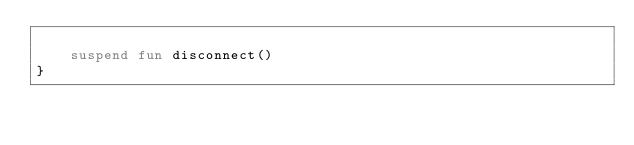<code> <loc_0><loc_0><loc_500><loc_500><_Kotlin_>
    suspend fun disconnect()
}
</code> 